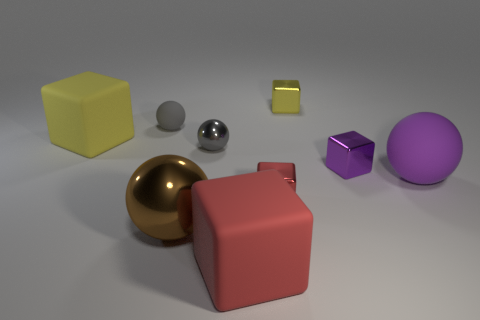What size is the red matte object that is the same shape as the big yellow rubber object?
Your answer should be very brief. Large. Is the number of tiny gray metal objects that are in front of the large purple object greater than the number of tiny yellow shiny objects?
Offer a terse response. No. Are the large ball in front of the big purple rubber object and the big purple ball made of the same material?
Make the answer very short. No. What is the size of the yellow thing in front of the tiny yellow shiny thing that is behind the yellow object that is in front of the yellow metallic cube?
Offer a very short reply. Large. The brown sphere that is made of the same material as the small purple thing is what size?
Offer a very short reply. Large. The tiny object that is both left of the yellow metal block and behind the large yellow block is what color?
Give a very brief answer. Gray. Do the metal thing in front of the tiny red metal thing and the red thing behind the big red matte cube have the same shape?
Make the answer very short. No. There is a tiny gray ball in front of the yellow rubber thing; what is it made of?
Your response must be concise. Metal. How many things are metal blocks behind the red shiny block or blue shiny blocks?
Your response must be concise. 2. Is the number of gray shiny balls to the right of the purple rubber ball the same as the number of gray metallic objects?
Offer a terse response. No. 